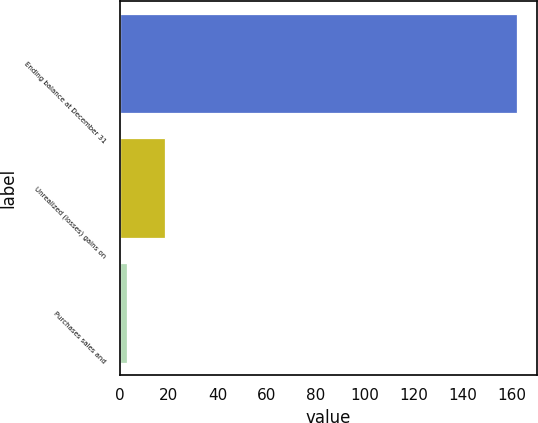Convert chart. <chart><loc_0><loc_0><loc_500><loc_500><bar_chart><fcel>Ending balance at December 31<fcel>Unrealized (losses) gains on<fcel>Purchases sales and<nl><fcel>162.3<fcel>18.3<fcel>3<nl></chart> 